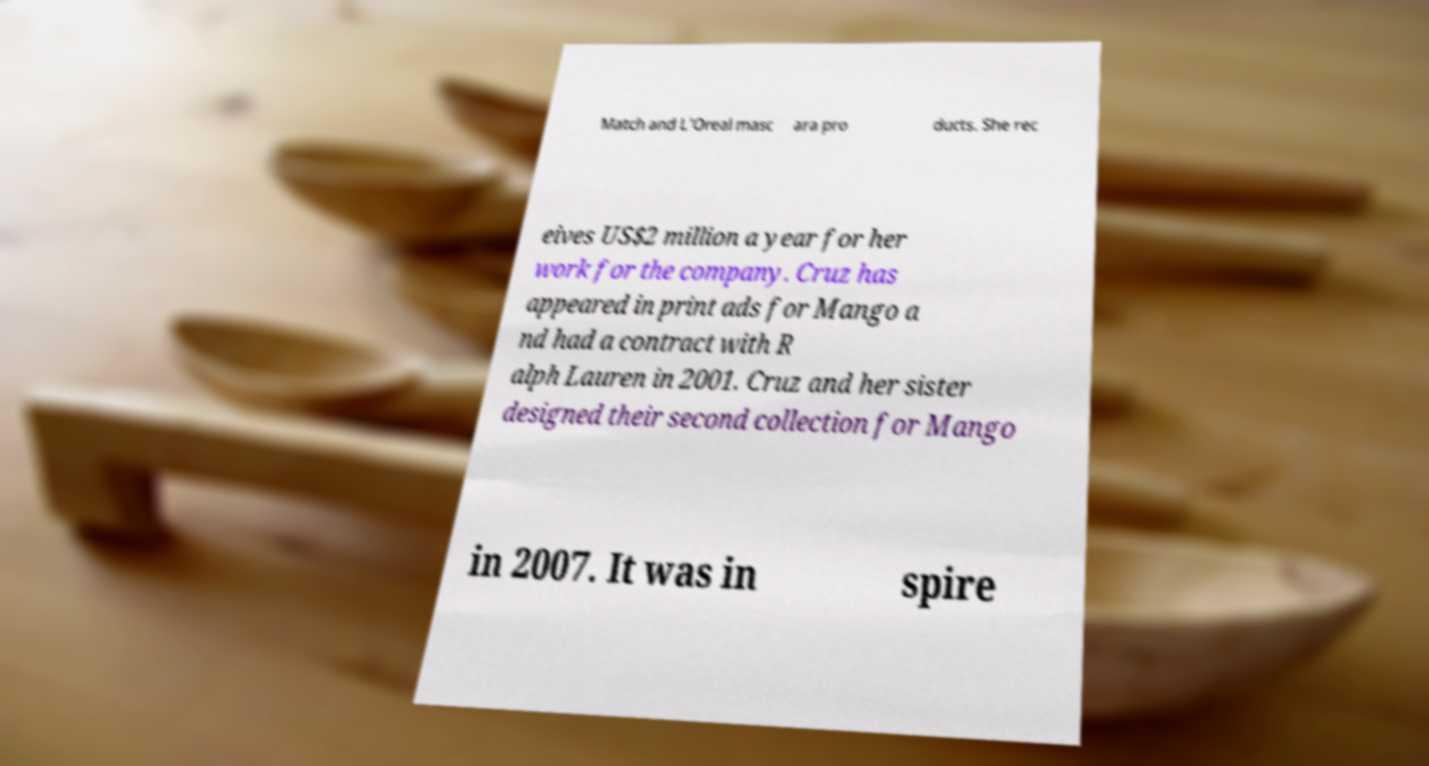Can you accurately transcribe the text from the provided image for me? Match and L'Oreal masc ara pro ducts. She rec eives US$2 million a year for her work for the company. Cruz has appeared in print ads for Mango a nd had a contract with R alph Lauren in 2001. Cruz and her sister designed their second collection for Mango in 2007. It was in spire 